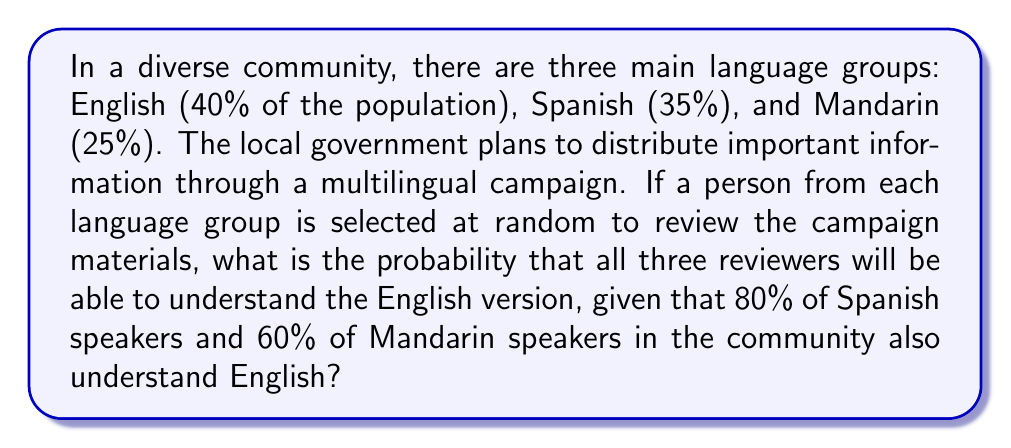Give your solution to this math problem. Let's approach this step-by-step:

1) First, we need to calculate the probability for each language group:

   a) For English speakers: P(English) = 1 (100% understand English)
   b) For Spanish speakers: P(Spanish) = 0.80 (80% understand English)
   c) For Mandarin speakers: P(Mandarin) = 0.60 (60% understand English)

2) Now, we need to find the probability of all three reviewers understanding English. This is a case of independent events, so we multiply the individual probabilities:

   $$P(\text{All understand}) = P(\text{English}) \times P(\text{Spanish}) \times P(\text{Mandarin})$$

3) Substituting the values:

   $$P(\text{All understand}) = 1 \times 0.80 \times 0.60$$

4) Calculating:

   $$P(\text{All understand}) = 0.48$$

5) Convert to a percentage:

   $$0.48 \times 100\% = 48\%$$

Therefore, the probability that all three randomly selected reviewers will understand the English version is 48% or 0.48.
Answer: 0.48 or 48% 